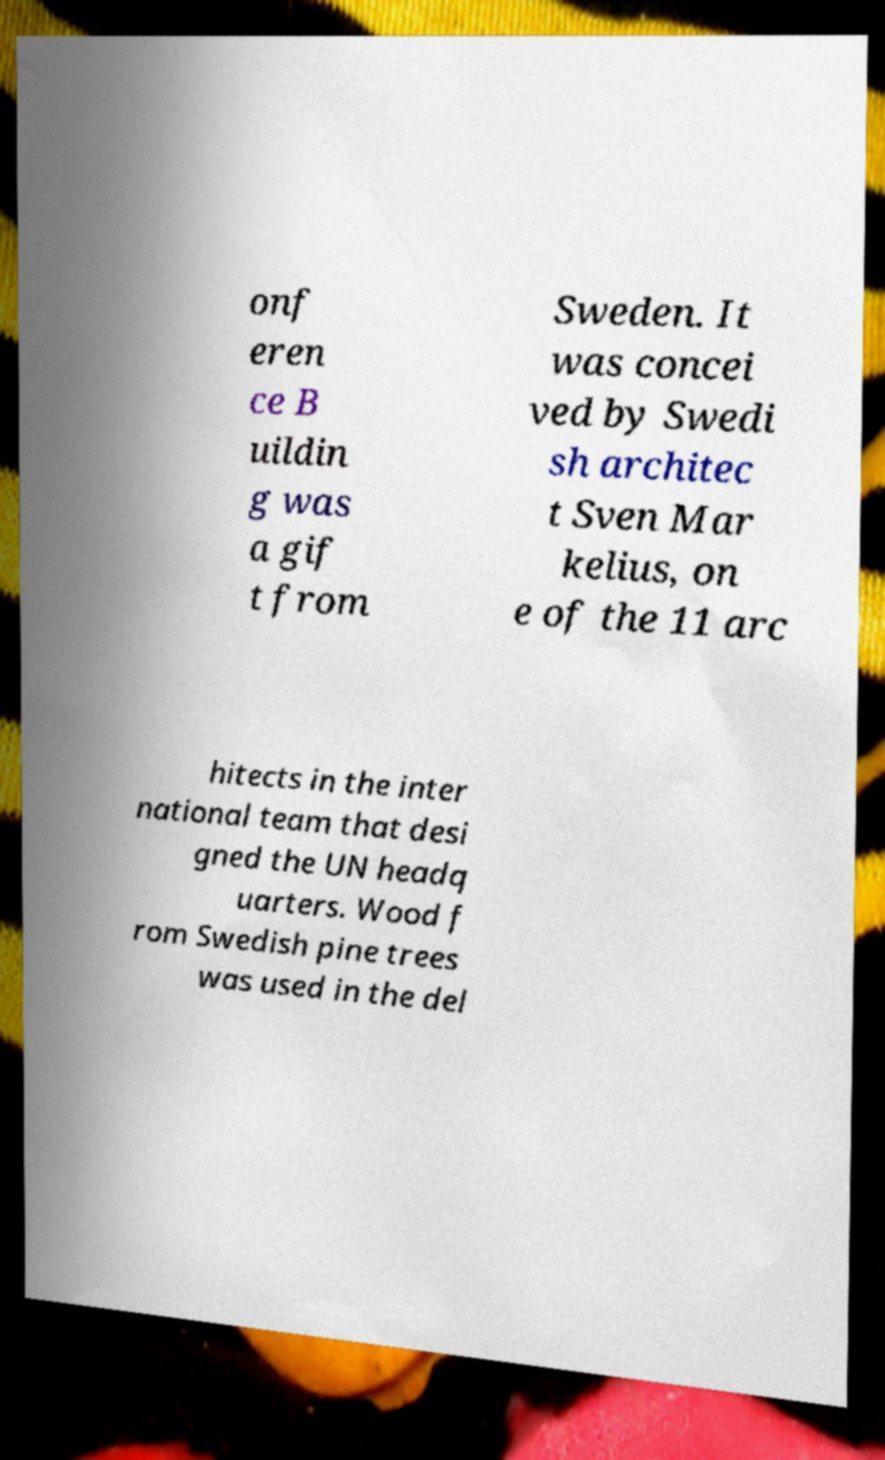Can you accurately transcribe the text from the provided image for me? onf eren ce B uildin g was a gif t from Sweden. It was concei ved by Swedi sh architec t Sven Mar kelius, on e of the 11 arc hitects in the inter national team that desi gned the UN headq uarters. Wood f rom Swedish pine trees was used in the del 